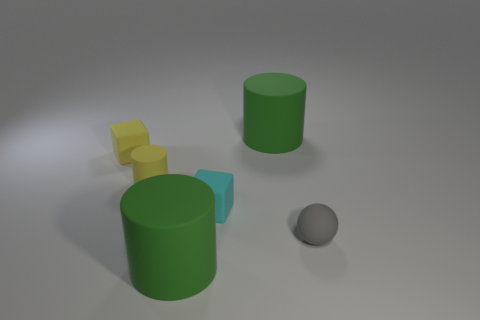There is a block to the left of the green matte cylinder in front of the tiny yellow rubber block; what is its size?
Your answer should be compact. Small. There is a large thing that is behind the yellow matte cylinder; is it the same shape as the yellow rubber thing in front of the yellow matte cube?
Offer a terse response. Yes. What color is the matte thing that is on the left side of the small matte sphere and right of the tiny cyan rubber block?
Your response must be concise. Green. Are there any rubber cylinders of the same color as the tiny ball?
Provide a short and direct response. No. The matte block to the right of the yellow rubber cylinder is what color?
Your answer should be very brief. Cyan. There is a big green cylinder that is behind the gray matte object; are there any gray matte balls that are on the left side of it?
Provide a short and direct response. No. Is the color of the ball the same as the matte cylinder that is in front of the cyan rubber object?
Offer a very short reply. No. Are there any large green cylinders made of the same material as the yellow cube?
Your response must be concise. Yes. How many small yellow rubber cubes are there?
Offer a terse response. 1. The large green cylinder that is behind the big green rubber cylinder that is in front of the gray matte sphere is made of what material?
Make the answer very short. Rubber. 